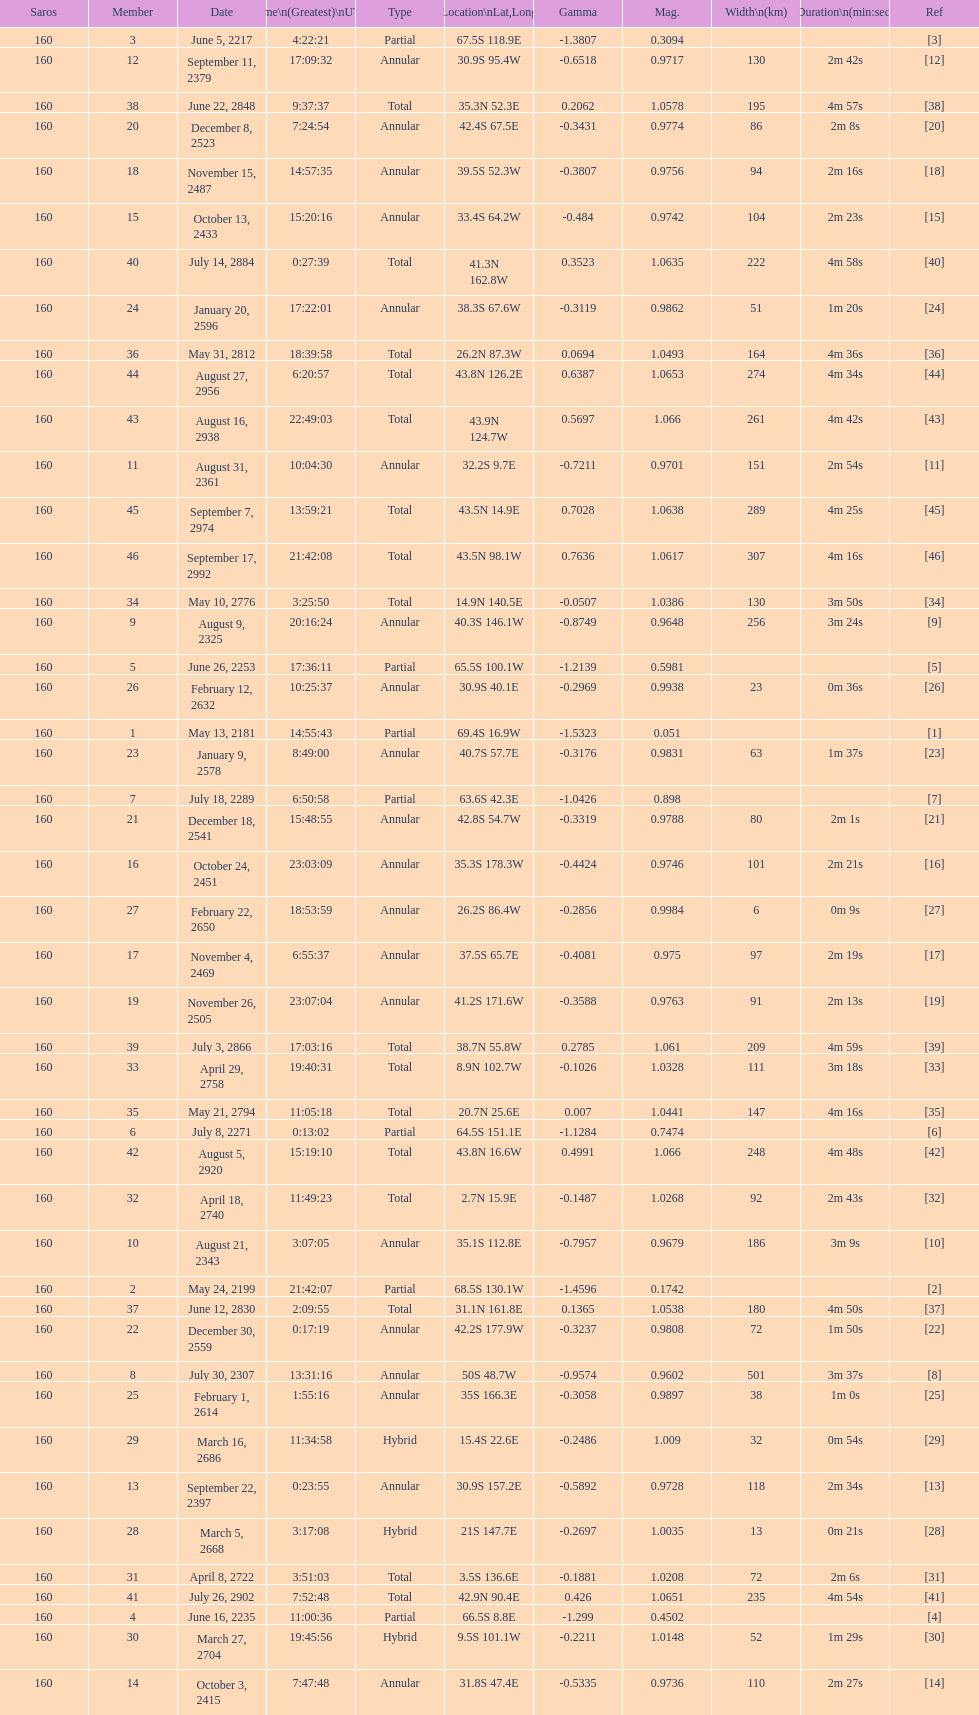When did the saros occur prior to october 3, 2415? 7:47:48. 